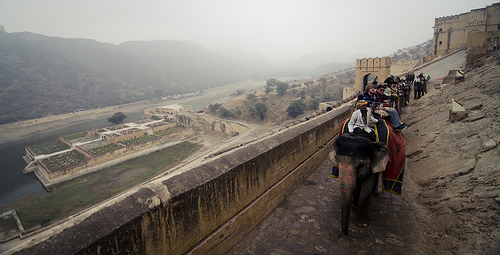Please provide a short description for this region: [0.62, 0.43, 0.83, 0.7]. The region describes an elephant, adorned with colorful cloths, carrying tourists—a common sight in areas promoting wildlife tourism. 